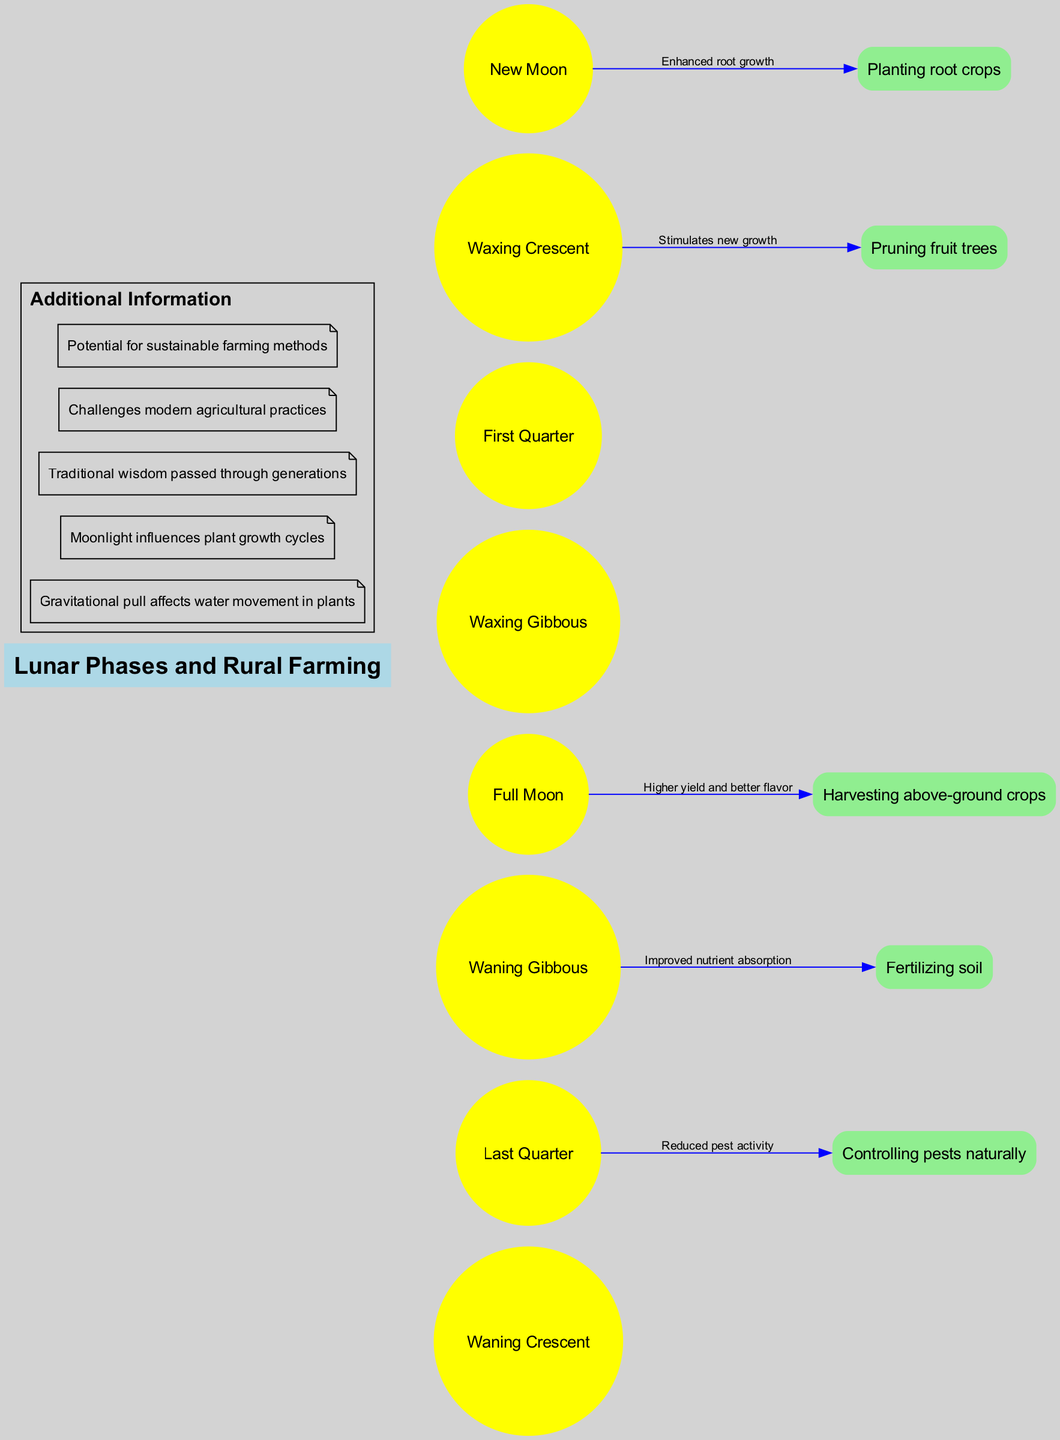What is the central node in the diagram? The central node is labeled "Lunar Phases and Rural Farming." It is the main topic that connects the various lunar phases and farming practices in the diagram.
Answer: Lunar Phases and Rural Farming How many lunar phases are represented in the diagram? The diagram lists eight lunar phases, which can be counted directly from the lunar phases section in the diagram.
Answer: 8 What is the belief associated with planting root crops during the New Moon phase? The belief connected to planting root crops during the New Moon phase is "Enhanced root growth," which is specified in the connection details for this phase.
Answer: Enhanced root growth Which farming practice is associated with the Full Moon phase? The Full Moon phase is connected to "Harvesting above-ground crops," as indicated in the connections between lunar phases and farming practices in the diagram.
Answer: Harvesting above-ground crops What is the relationship between the Waning Gibbous phase and fertilizing soil? The relationship shown is that during the Waning Gibbous phase, it is believed to improve nutrient absorption when fertilizing soil, as per the connection in the diagram.
Answer: Improved nutrient absorption What belief is linked to controlling pests naturally during the Last Quarter phase? The belief linked to controlling pests during the Last Quarter phase is "Reduced pest activity," which is directly presented in the diagram's connection description.
Answer: Reduced pest activity Which lunar phase correlates with pruning fruit trees? Pruning fruit trees is correlated with the Waxing Crescent phase, highlighted in the diagram as one of the practices associated with this phase.
Answer: Waxing Crescent Which two practices are linked to the New Moon and Last Quarter phases, respectively? The New Moon phase is linked to "Planting root crops," while the Last Quarter phase is linked to "Controlling pests naturally." This can be found by examining the specific connections shown in the diagram.
Answer: Planting root crops; Controlling pests naturally How many farming practices are connected to lunar phases in the diagram? There are five farming practices listed, all of which have connections to specific lunar phases indicated in the connections section of the diagram.
Answer: 5 What additional information is mentioned in the diagram regarding lunar phases? The diagram includes various pieces of additional information such as "Gravitational pull affects water movement in plants" and "Moonlight influences plant growth cycles," which are found in the additional info section.
Answer: Gravitational pull affects water movement in plants; Moonlight influences plant growth cycles 